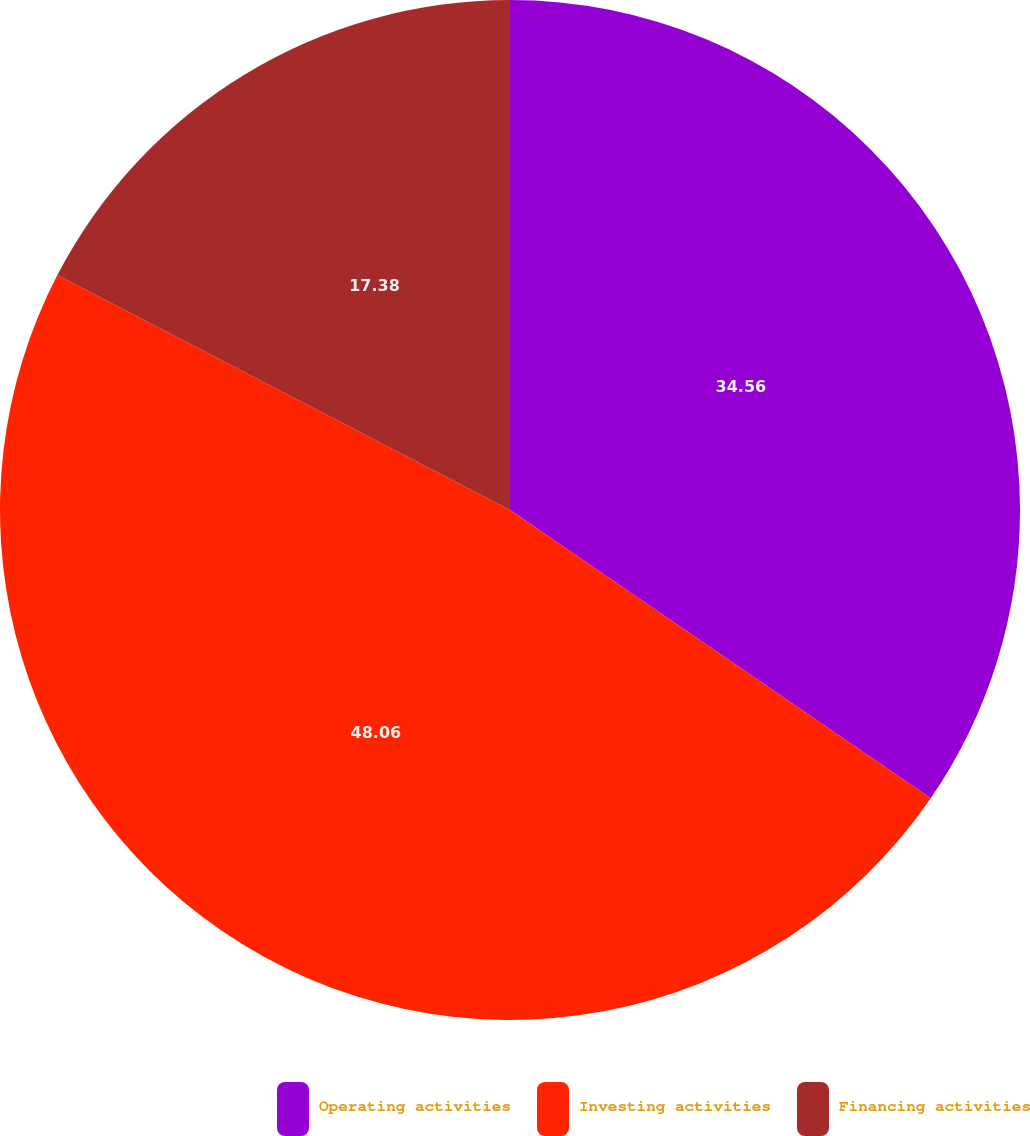Convert chart to OTSL. <chart><loc_0><loc_0><loc_500><loc_500><pie_chart><fcel>Operating activities<fcel>Investing activities<fcel>Financing activities<nl><fcel>34.56%<fcel>48.06%<fcel>17.38%<nl></chart> 